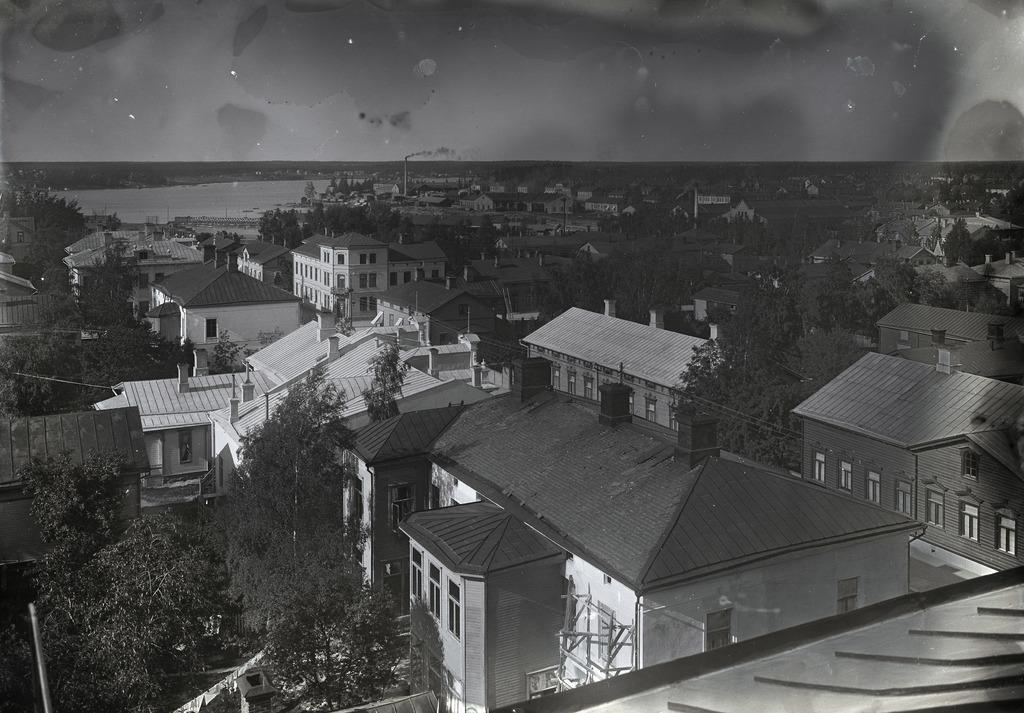Could you give a brief overview of what you see in this image? In this image I can see few buildings, windows, trees, wires, pole and water. The image is in black and white. 